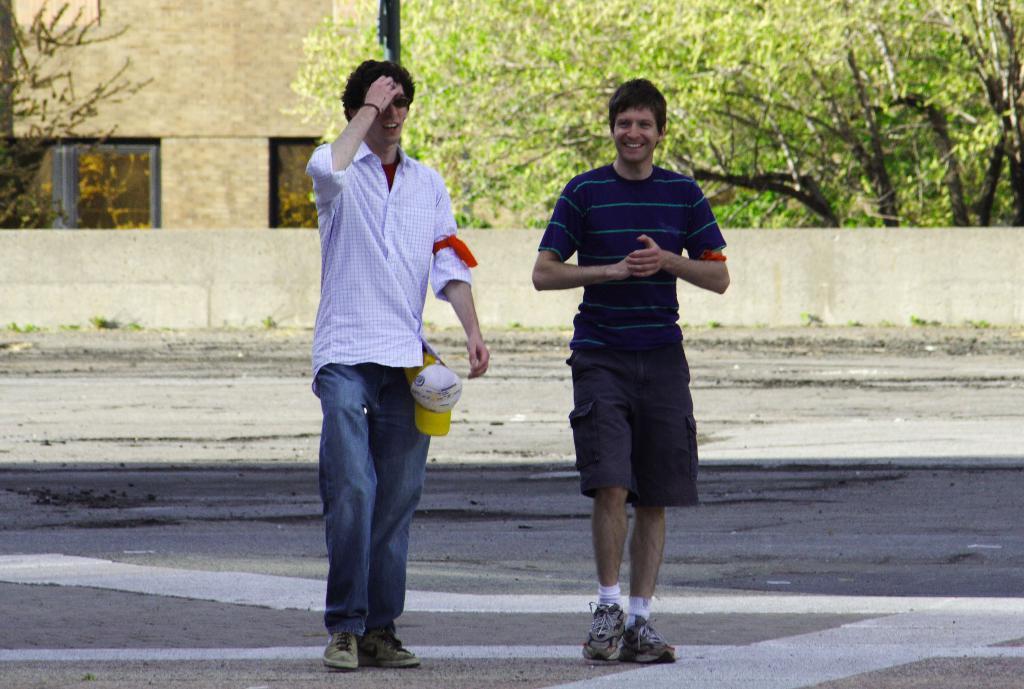In one or two sentences, can you explain what this image depicts? In this image there are two persons walking on a road, in the background there is a wall, trees and a building. 